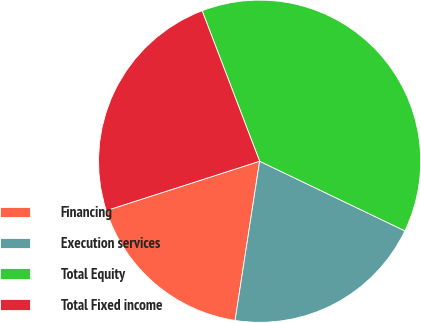Convert chart to OTSL. <chart><loc_0><loc_0><loc_500><loc_500><pie_chart><fcel>Financing<fcel>Execution services<fcel>Total Equity<fcel>Total Fixed income<nl><fcel>17.61%<fcel>20.32%<fcel>37.93%<fcel>24.15%<nl></chart> 